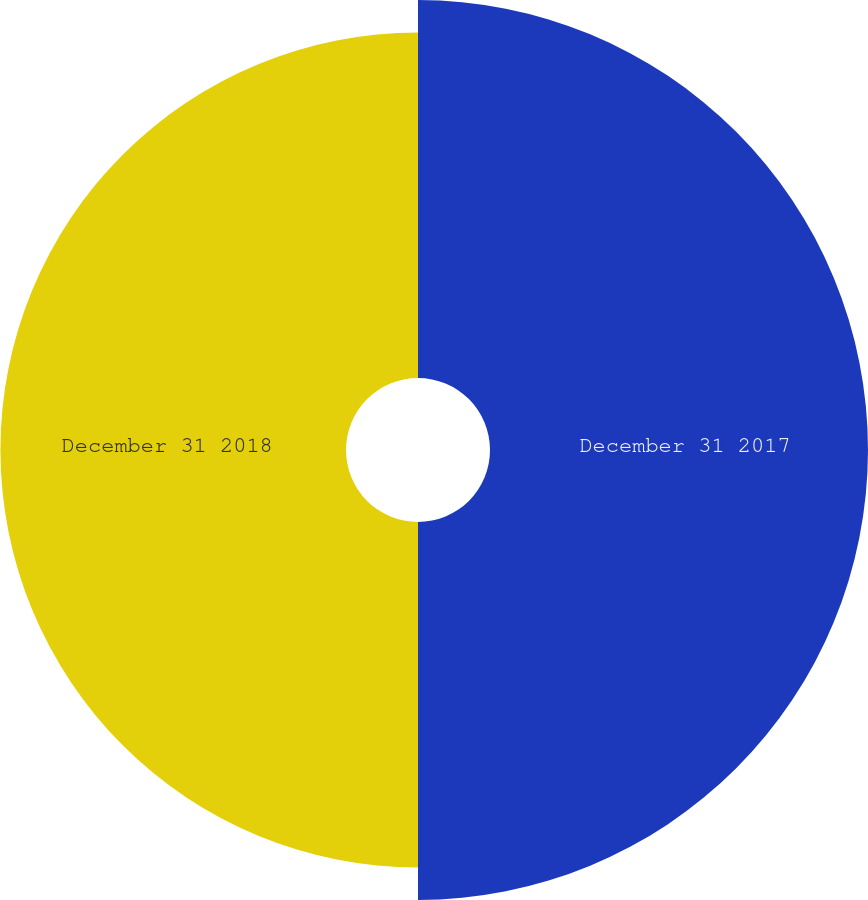Convert chart. <chart><loc_0><loc_0><loc_500><loc_500><pie_chart><fcel>December 31 2017<fcel>December 31 2018<nl><fcel>52.24%<fcel>47.76%<nl></chart> 